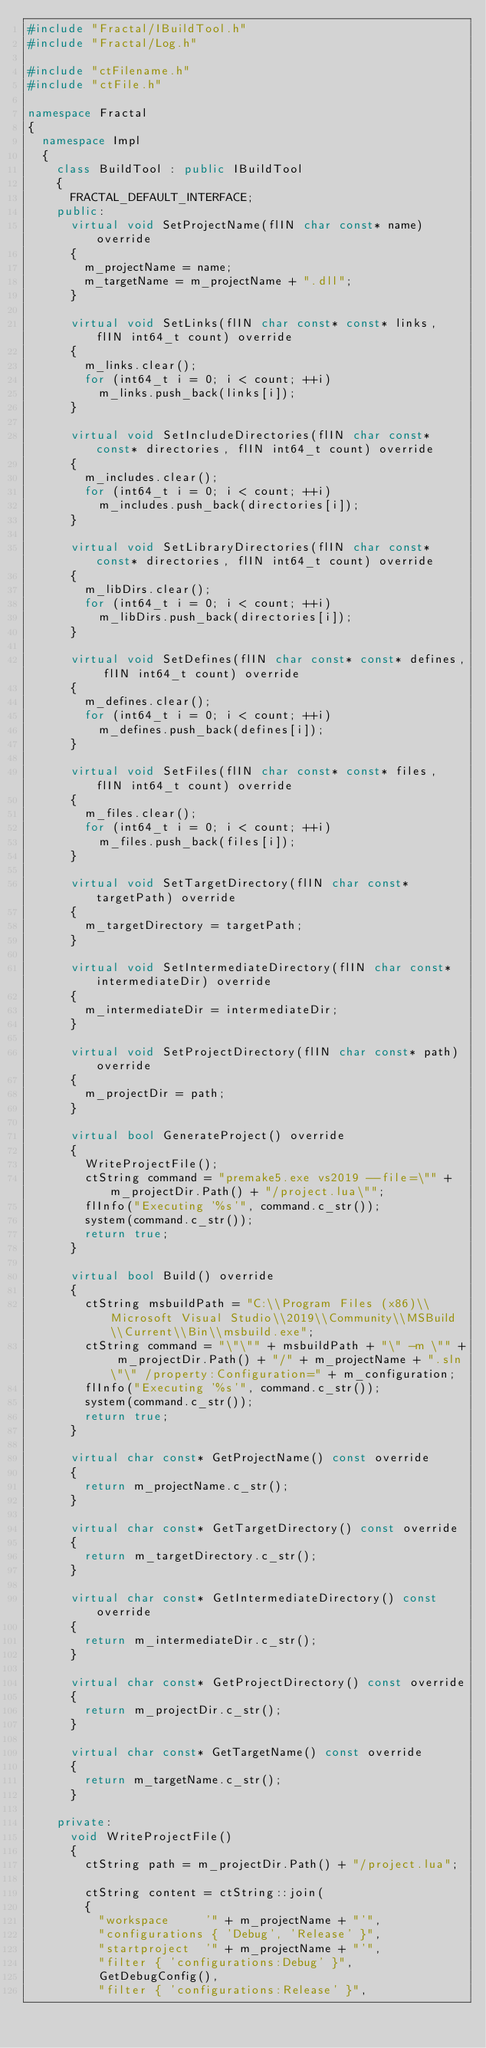Convert code to text. <code><loc_0><loc_0><loc_500><loc_500><_C++_>#include "Fractal/IBuildTool.h"
#include "Fractal/Log.h"

#include "ctFilename.h"
#include "ctFile.h"

namespace Fractal
{
  namespace Impl
  {
    class BuildTool : public IBuildTool
    {
      FRACTAL_DEFAULT_INTERFACE;
    public:
      virtual void SetProjectName(flIN char const* name) override
      {
        m_projectName = name;
        m_targetName = m_projectName + ".dll";
      }

      virtual void SetLinks(flIN char const* const* links, flIN int64_t count) override
      {
        m_links.clear();
        for (int64_t i = 0; i < count; ++i)
          m_links.push_back(links[i]);
      }

      virtual void SetIncludeDirectories(flIN char const* const* directories, flIN int64_t count) override
      {
        m_includes.clear();
        for (int64_t i = 0; i < count; ++i)
          m_includes.push_back(directories[i]);
      }

      virtual void SetLibraryDirectories(flIN char const* const* directories, flIN int64_t count) override
      {
        m_libDirs.clear();
        for (int64_t i = 0; i < count; ++i)
          m_libDirs.push_back(directories[i]);
      }

      virtual void SetDefines(flIN char const* const* defines, flIN int64_t count) override
      {
        m_defines.clear();
        for (int64_t i = 0; i < count; ++i)
          m_defines.push_back(defines[i]);
      }

      virtual void SetFiles(flIN char const* const* files, flIN int64_t count) override
      {
        m_files.clear();
        for (int64_t i = 0; i < count; ++i)
          m_files.push_back(files[i]);
      }

      virtual void SetTargetDirectory(flIN char const* targetPath) override
      {
        m_targetDirectory = targetPath;
      }

      virtual void SetIntermediateDirectory(flIN char const* intermediateDir) override
      {
        m_intermediateDir = intermediateDir;
      }

      virtual void SetProjectDirectory(flIN char const* path) override
      {
        m_projectDir = path;
      }

      virtual bool GenerateProject() override
      {
        WriteProjectFile();
        ctString command = "premake5.exe vs2019 --file=\"" + m_projectDir.Path() + "/project.lua\"";
        flInfo("Executing '%s'", command.c_str());
        system(command.c_str());
        return true;
      }

      virtual bool Build() override
      {
        ctString msbuildPath = "C:\\Program Files (x86)\\Microsoft Visual Studio\\2019\\Community\\MSBuild\\Current\\Bin\\msbuild.exe";
        ctString command = "\"\"" + msbuildPath + "\" -m \"" + m_projectDir.Path() + "/" + m_projectName + ".sln\"\" /property:Configuration=" + m_configuration;
        flInfo("Executing '%s'", command.c_str());
        system(command.c_str());
        return true;
      }

      virtual char const* GetProjectName() const override
      {
        return m_projectName.c_str();
      }

      virtual char const* GetTargetDirectory() const override
      {
        return m_targetDirectory.c_str();
      }

      virtual char const* GetIntermediateDirectory() const override
      {
        return m_intermediateDir.c_str();
      }

      virtual char const* GetProjectDirectory() const override
      {
        return m_projectDir.c_str();
      }

      virtual char const* GetTargetName() const override
      {
        return m_targetName.c_str();
      }

    private:
      void WriteProjectFile()
      {
        ctString path = m_projectDir.Path() + "/project.lua";

        ctString content = ctString::join(
        {
          "workspace     '" + m_projectName + "'",
          "configurations { 'Debug', 'Release' }",
          "startproject  '" + m_projectName + "'",
          "filter { 'configurations:Debug' }",
          GetDebugConfig(),
          "filter { 'configurations:Release' }",</code> 